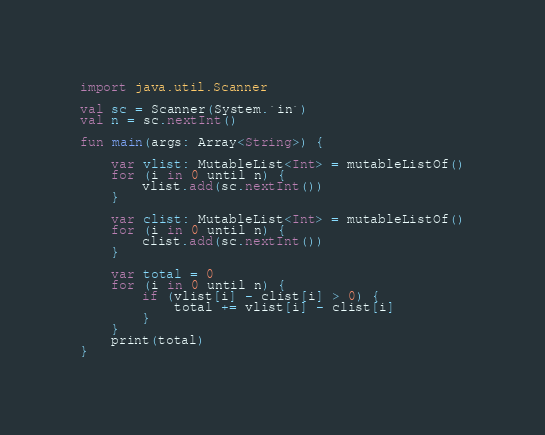Convert code to text. <code><loc_0><loc_0><loc_500><loc_500><_Kotlin_>import java.util.Scanner

val sc = Scanner(System.`in`)
val n = sc.nextInt()

fun main(args: Array<String>) {

    var vlist: MutableList<Int> = mutableListOf()
    for (i in 0 until n) {
        vlist.add(sc.nextInt())
    }

    var clist: MutableList<Int> = mutableListOf()
    for (i in 0 until n) {
        clist.add(sc.nextInt())
    }

    var total = 0
    for (i in 0 until n) {
        if (vlist[i] - clist[i] > 0) {
            total += vlist[i] - clist[i]
        }
    }
    print(total)
}</code> 